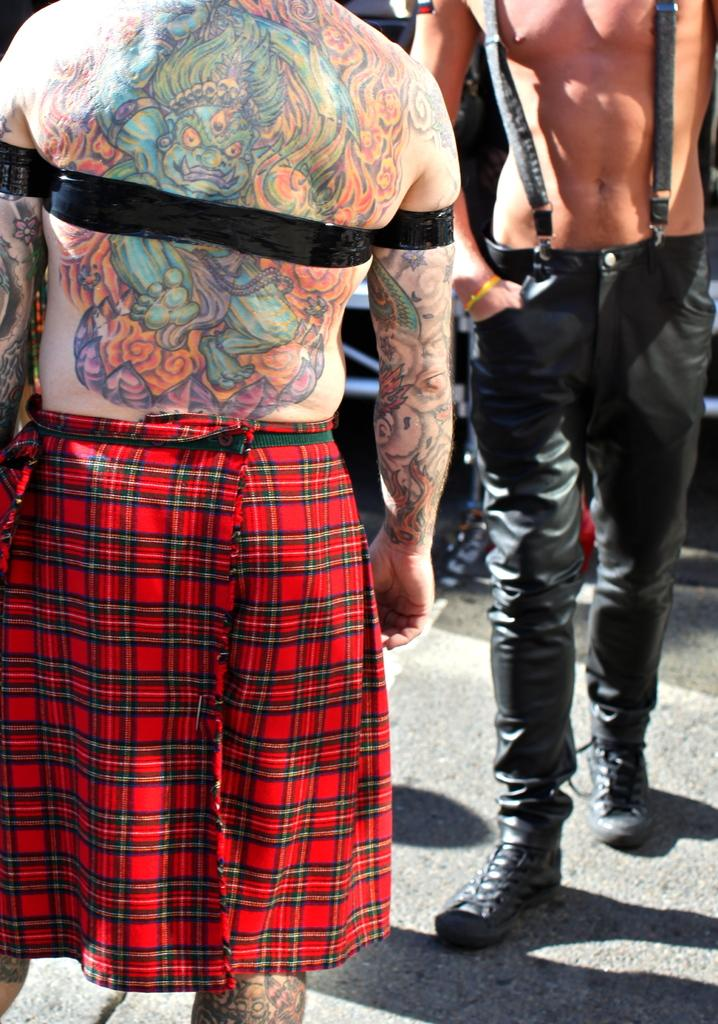What are the people in the image doing? The people in the image are standing on a road. Can you describe any distinguishing features of one of the individuals? One person has tattoos on their body. What is the name of the ship that is visible in the image? There is no ship present in the image; it features people standing on a road. 